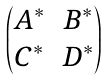<formula> <loc_0><loc_0><loc_500><loc_500>\begin{pmatrix} A ^ { \ast } & B ^ { \ast } \\ C ^ { \ast } & D ^ { \ast } \end{pmatrix}</formula> 